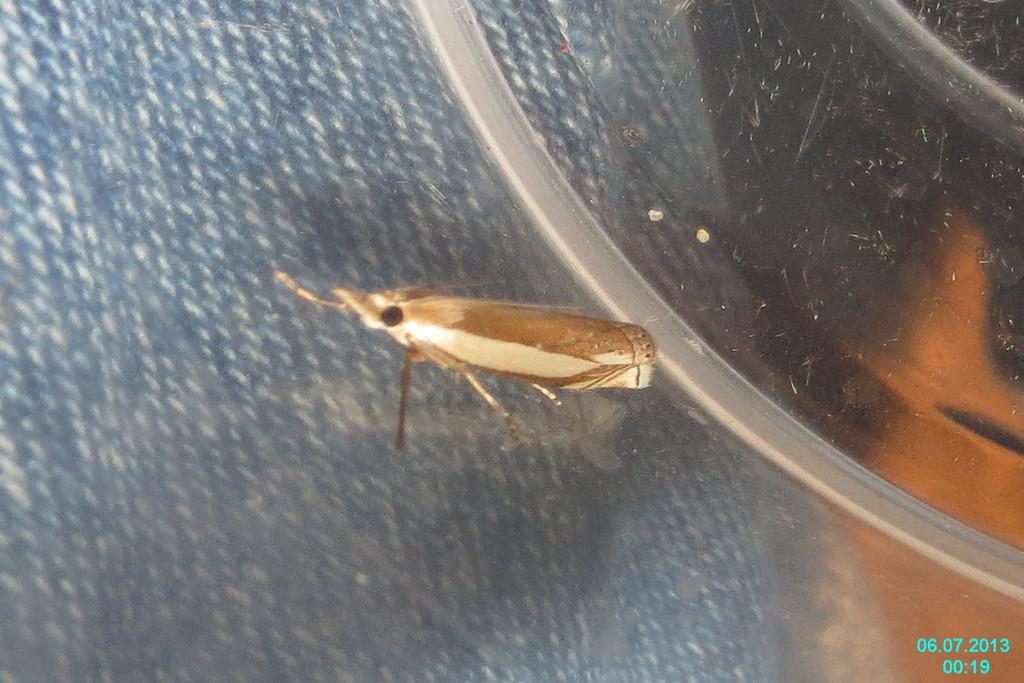What type of creature is present in the image? There is an insect in the image. Is there any additional information provided in the image? Yes, there is a timestamp at the right bottom of the image. What direction is the grandmother walking in the image? There is no grandmother present in the image, only an insect and a timestamp. 